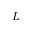Convert formula to latex. <formula><loc_0><loc_0><loc_500><loc_500>L</formula> 